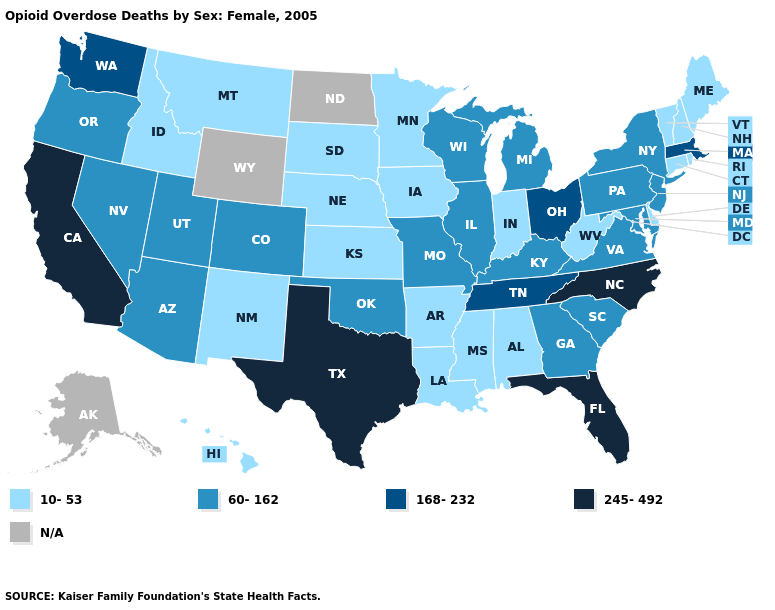What is the lowest value in the West?
Quick response, please. 10-53. What is the lowest value in the West?
Keep it brief. 10-53. How many symbols are there in the legend?
Concise answer only. 5. Name the states that have a value in the range N/A?
Be succinct. Alaska, North Dakota, Wyoming. How many symbols are there in the legend?
Be succinct. 5. Does the map have missing data?
Keep it brief. Yes. Which states have the lowest value in the USA?
Short answer required. Alabama, Arkansas, Connecticut, Delaware, Hawaii, Idaho, Indiana, Iowa, Kansas, Louisiana, Maine, Minnesota, Mississippi, Montana, Nebraska, New Hampshire, New Mexico, Rhode Island, South Dakota, Vermont, West Virginia. Name the states that have a value in the range N/A?
Answer briefly. Alaska, North Dakota, Wyoming. What is the value of Oklahoma?
Write a very short answer. 60-162. What is the value of Montana?
Short answer required. 10-53. What is the value of Connecticut?
Write a very short answer. 10-53. What is the value of Tennessee?
Concise answer only. 168-232. Name the states that have a value in the range N/A?
Write a very short answer. Alaska, North Dakota, Wyoming. Does the map have missing data?
Be succinct. Yes. Name the states that have a value in the range 168-232?
Concise answer only. Massachusetts, Ohio, Tennessee, Washington. 